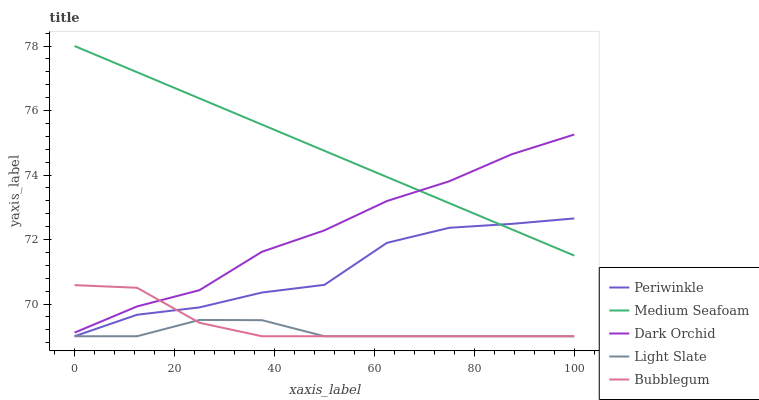Does Light Slate have the minimum area under the curve?
Answer yes or no. Yes. Does Medium Seafoam have the maximum area under the curve?
Answer yes or no. Yes. Does Bubblegum have the minimum area under the curve?
Answer yes or no. No. Does Bubblegum have the maximum area under the curve?
Answer yes or no. No. Is Medium Seafoam the smoothest?
Answer yes or no. Yes. Is Periwinkle the roughest?
Answer yes or no. Yes. Is Bubblegum the smoothest?
Answer yes or no. No. Is Bubblegum the roughest?
Answer yes or no. No. Does Medium Seafoam have the lowest value?
Answer yes or no. No. Does Medium Seafoam have the highest value?
Answer yes or no. Yes. Does Bubblegum have the highest value?
Answer yes or no. No. Is Periwinkle less than Dark Orchid?
Answer yes or no. Yes. Is Medium Seafoam greater than Bubblegum?
Answer yes or no. Yes. Does Periwinkle intersect Dark Orchid?
Answer yes or no. No. 